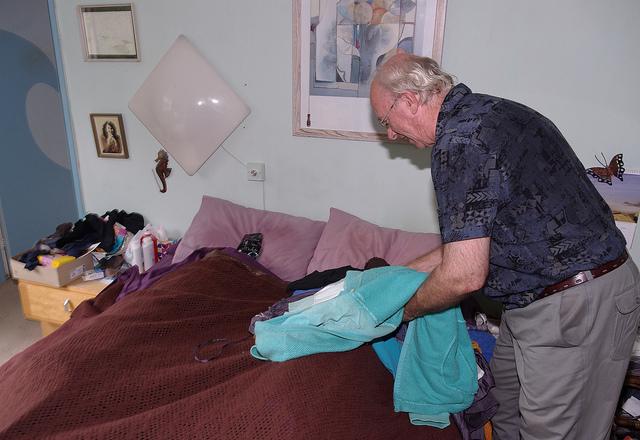Who is in the bed?
Write a very short answer. No 1. Do these people appear to be excited?
Short answer required. Yes. What is the man holding?
Keep it brief. Clothes. What room is this?
Keep it brief. Bedroom. Is anyone standing?
Write a very short answer. Yes. Is the pillowcase the same color as the sheet?
Quick response, please. No. Is this person getting ready to sleep?
Be succinct. No. What room are they in?
Short answer required. Bedroom. Who is the old man in the photo?
Write a very short answer. Grandpa. What type of animal fixture is mounted to the wall?
Quick response, please. Seahorse. What is the man looking into?
Quick response, please. Clothes. What is the man doing?
Answer briefly. Folding clothes. 